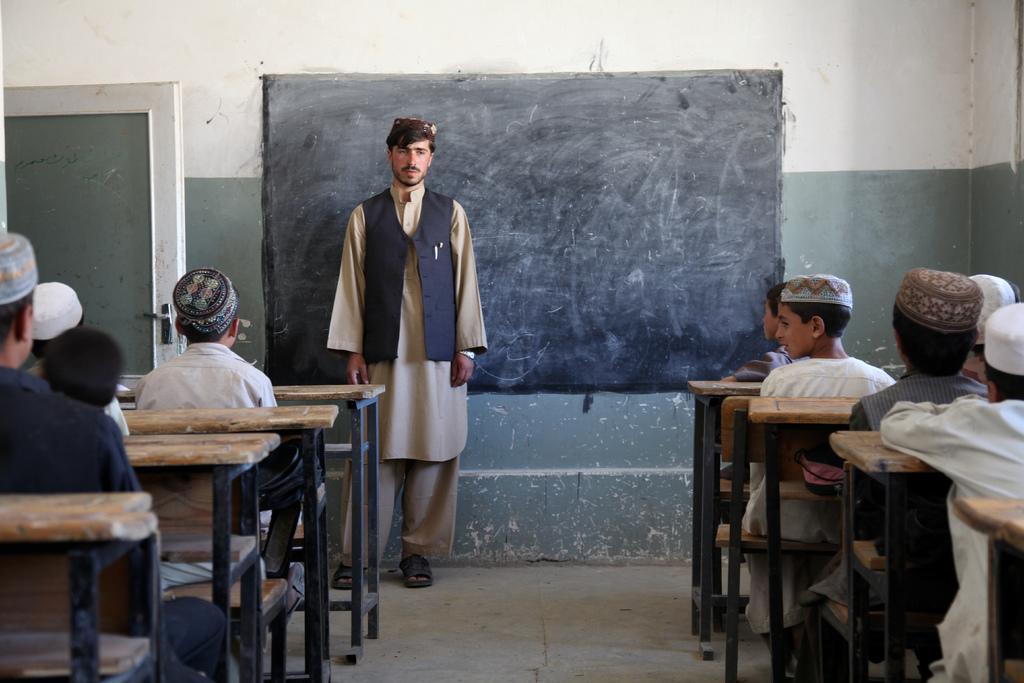Describe this image in one or two sentences. In the image we can see there are kids sitting on the bench and in front of them there is a man standing near the blackboard. 